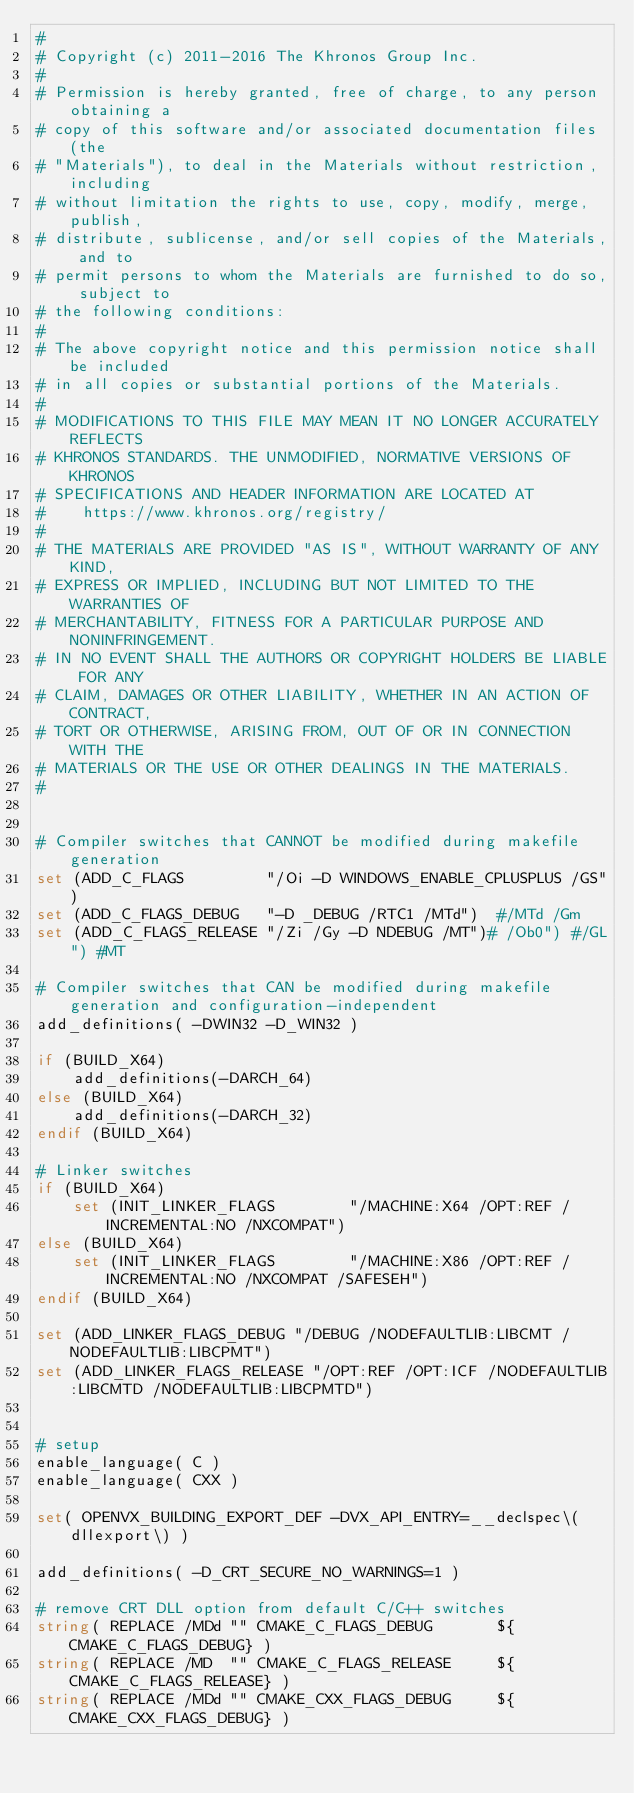Convert code to text. <code><loc_0><loc_0><loc_500><loc_500><_CMake_>#
# Copyright (c) 2011-2016 The Khronos Group Inc.
#
# Permission is hereby granted, free of charge, to any person obtaining a
# copy of this software and/or associated documentation files (the
# "Materials"), to deal in the Materials without restriction, including
# without limitation the rights to use, copy, modify, merge, publish,
# distribute, sublicense, and/or sell copies of the Materials, and to
# permit persons to whom the Materials are furnished to do so, subject to
# the following conditions:
#
# The above copyright notice and this permission notice shall be included
# in all copies or substantial portions of the Materials.
#
# MODIFICATIONS TO THIS FILE MAY MEAN IT NO LONGER ACCURATELY REFLECTS
# KHRONOS STANDARDS. THE UNMODIFIED, NORMATIVE VERSIONS OF KHRONOS
# SPECIFICATIONS AND HEADER INFORMATION ARE LOCATED AT
#    https://www.khronos.org/registry/
#
# THE MATERIALS ARE PROVIDED "AS IS", WITHOUT WARRANTY OF ANY KIND,
# EXPRESS OR IMPLIED, INCLUDING BUT NOT LIMITED TO THE WARRANTIES OF
# MERCHANTABILITY, FITNESS FOR A PARTICULAR PURPOSE AND NONINFRINGEMENT.
# IN NO EVENT SHALL THE AUTHORS OR COPYRIGHT HOLDERS BE LIABLE FOR ANY
# CLAIM, DAMAGES OR OTHER LIABILITY, WHETHER IN AN ACTION OF CONTRACT,
# TORT OR OTHERWISE, ARISING FROM, OUT OF OR IN CONNECTION WITH THE
# MATERIALS OR THE USE OR OTHER DEALINGS IN THE MATERIALS.
#


# Compiler switches that CANNOT be modified during makefile generation
set (ADD_C_FLAGS         "/Oi -D WINDOWS_ENABLE_CPLUSPLUS /GS")
set (ADD_C_FLAGS_DEBUG   "-D _DEBUG /RTC1 /MTd")  #/MTd /Gm
set (ADD_C_FLAGS_RELEASE "/Zi /Gy -D NDEBUG /MT")# /Ob0") #/GL") #MT

# Compiler switches that CAN be modified during makefile generation and configuration-independent
add_definitions( -DWIN32 -D_WIN32 )

if (BUILD_X64)
    add_definitions(-DARCH_64)
else (BUILD_X64)
    add_definitions(-DARCH_32)
endif (BUILD_X64)

# Linker switches
if (BUILD_X64)
    set (INIT_LINKER_FLAGS        "/MACHINE:X64 /OPT:REF /INCREMENTAL:NO /NXCOMPAT")
else (BUILD_X64)
    set (INIT_LINKER_FLAGS        "/MACHINE:X86 /OPT:REF /INCREMENTAL:NO /NXCOMPAT /SAFESEH")
endif (BUILD_X64)

set (ADD_LINKER_FLAGS_DEBUG "/DEBUG /NODEFAULTLIB:LIBCMT /NODEFAULTLIB:LIBCPMT")
set (ADD_LINKER_FLAGS_RELEASE "/OPT:REF /OPT:ICF /NODEFAULTLIB:LIBCMTD /NODEFAULTLIB:LIBCPMTD")


# setup
enable_language( C )
enable_language( CXX )

set( OPENVX_BUILDING_EXPORT_DEF -DVX_API_ENTRY=__declspec\(dllexport\) )

add_definitions( -D_CRT_SECURE_NO_WARNINGS=1 )

# remove CRT DLL option from default C/C++ switches
string( REPLACE /MDd "" CMAKE_C_FLAGS_DEBUG       ${CMAKE_C_FLAGS_DEBUG} )
string( REPLACE /MD  "" CMAKE_C_FLAGS_RELEASE     ${CMAKE_C_FLAGS_RELEASE} )
string( REPLACE /MDd "" CMAKE_CXX_FLAGS_DEBUG     ${CMAKE_CXX_FLAGS_DEBUG} )</code> 